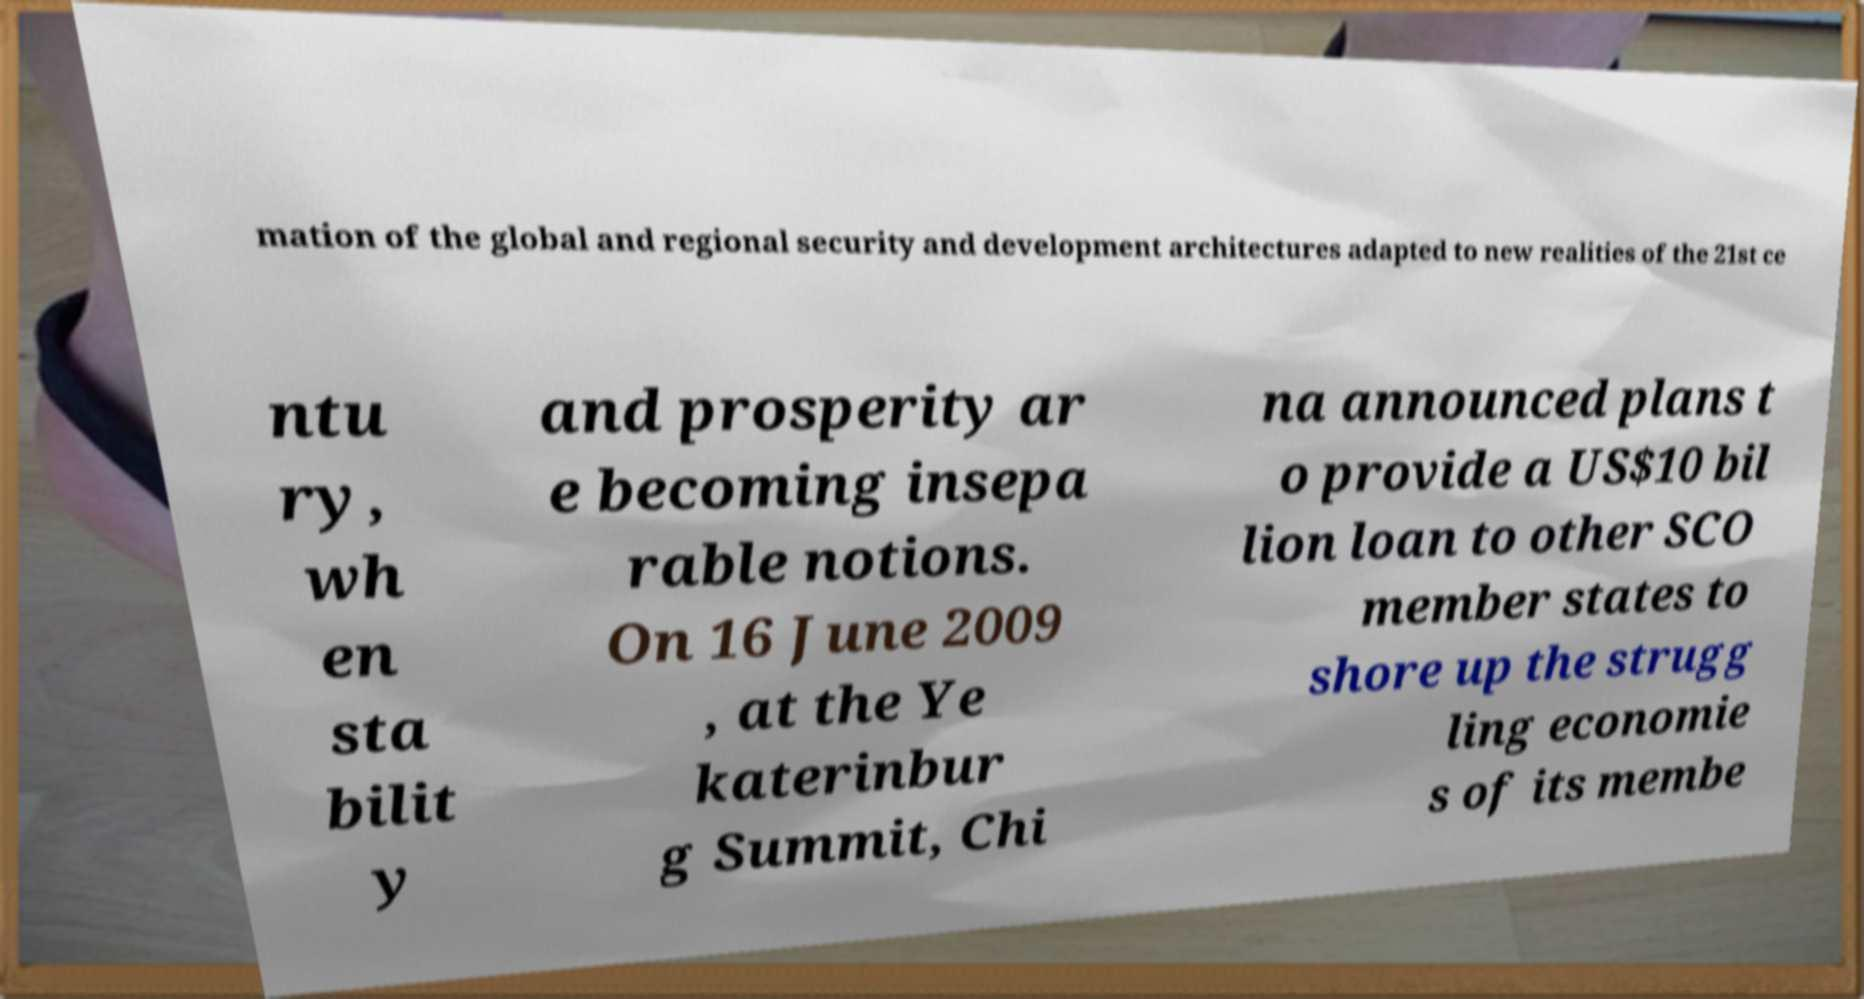For documentation purposes, I need the text within this image transcribed. Could you provide that? mation of the global and regional security and development architectures adapted to new realities of the 21st ce ntu ry, wh en sta bilit y and prosperity ar e becoming insepa rable notions. On 16 June 2009 , at the Ye katerinbur g Summit, Chi na announced plans t o provide a US$10 bil lion loan to other SCO member states to shore up the strugg ling economie s of its membe 